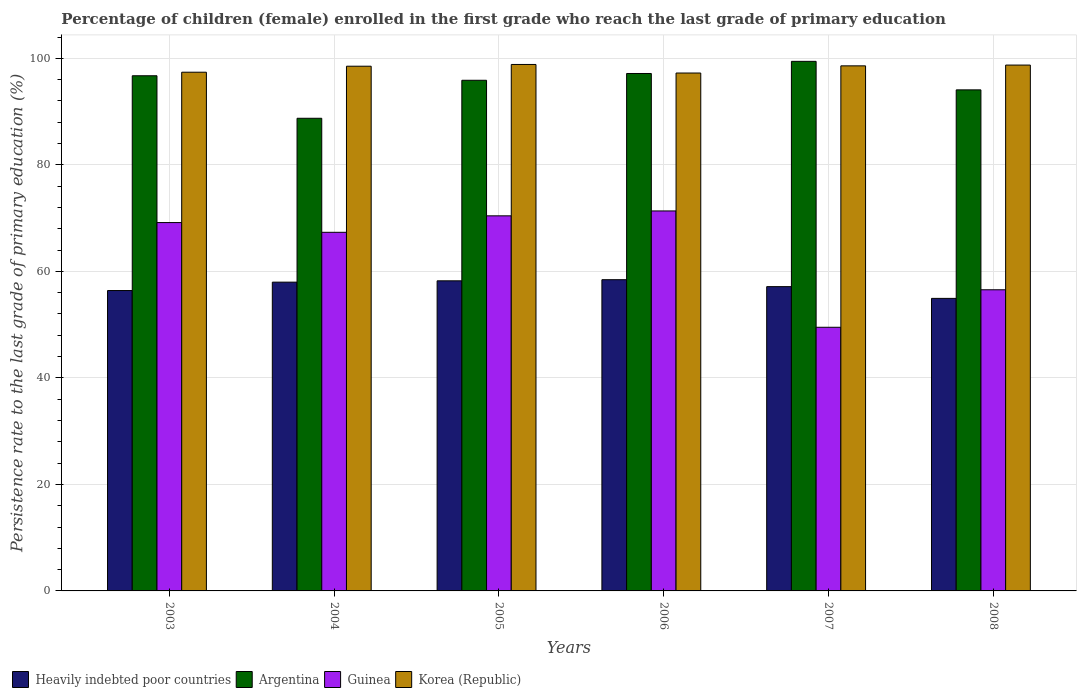How many different coloured bars are there?
Your answer should be very brief. 4. How many bars are there on the 5th tick from the right?
Your answer should be compact. 4. In how many cases, is the number of bars for a given year not equal to the number of legend labels?
Make the answer very short. 0. What is the persistence rate of children in Korea (Republic) in 2005?
Provide a short and direct response. 98.84. Across all years, what is the maximum persistence rate of children in Heavily indebted poor countries?
Offer a very short reply. 58.43. Across all years, what is the minimum persistence rate of children in Heavily indebted poor countries?
Provide a short and direct response. 54.93. In which year was the persistence rate of children in Heavily indebted poor countries maximum?
Your answer should be very brief. 2006. In which year was the persistence rate of children in Argentina minimum?
Offer a terse response. 2004. What is the total persistence rate of children in Guinea in the graph?
Your response must be concise. 384.29. What is the difference between the persistence rate of children in Korea (Republic) in 2003 and that in 2007?
Ensure brevity in your answer.  -1.2. What is the difference between the persistence rate of children in Heavily indebted poor countries in 2007 and the persistence rate of children in Korea (Republic) in 2006?
Your response must be concise. -40.1. What is the average persistence rate of children in Guinea per year?
Ensure brevity in your answer.  64.05. In the year 2007, what is the difference between the persistence rate of children in Argentina and persistence rate of children in Heavily indebted poor countries?
Provide a succinct answer. 42.3. In how many years, is the persistence rate of children in Guinea greater than 64 %?
Your response must be concise. 4. What is the ratio of the persistence rate of children in Argentina in 2003 to that in 2008?
Offer a very short reply. 1.03. Is the persistence rate of children in Guinea in 2003 less than that in 2008?
Ensure brevity in your answer.  No. What is the difference between the highest and the second highest persistence rate of children in Heavily indebted poor countries?
Make the answer very short. 0.21. What is the difference between the highest and the lowest persistence rate of children in Korea (Republic)?
Keep it short and to the point. 1.61. In how many years, is the persistence rate of children in Korea (Republic) greater than the average persistence rate of children in Korea (Republic) taken over all years?
Provide a short and direct response. 4. Is the sum of the persistence rate of children in Heavily indebted poor countries in 2006 and 2008 greater than the maximum persistence rate of children in Guinea across all years?
Provide a succinct answer. Yes. Is it the case that in every year, the sum of the persistence rate of children in Guinea and persistence rate of children in Heavily indebted poor countries is greater than the sum of persistence rate of children in Argentina and persistence rate of children in Korea (Republic)?
Make the answer very short. No. What does the 2nd bar from the right in 2006 represents?
Make the answer very short. Guinea. Is it the case that in every year, the sum of the persistence rate of children in Guinea and persistence rate of children in Heavily indebted poor countries is greater than the persistence rate of children in Korea (Republic)?
Your response must be concise. Yes. Where does the legend appear in the graph?
Give a very brief answer. Bottom left. What is the title of the graph?
Provide a short and direct response. Percentage of children (female) enrolled in the first grade who reach the last grade of primary education. What is the label or title of the X-axis?
Provide a succinct answer. Years. What is the label or title of the Y-axis?
Your answer should be very brief. Persistence rate to the last grade of primary education (%). What is the Persistence rate to the last grade of primary education (%) in Heavily indebted poor countries in 2003?
Your response must be concise. 56.4. What is the Persistence rate to the last grade of primary education (%) in Argentina in 2003?
Your answer should be compact. 96.72. What is the Persistence rate to the last grade of primary education (%) of Guinea in 2003?
Make the answer very short. 69.16. What is the Persistence rate to the last grade of primary education (%) of Korea (Republic) in 2003?
Provide a succinct answer. 97.39. What is the Persistence rate to the last grade of primary education (%) in Heavily indebted poor countries in 2004?
Keep it short and to the point. 57.97. What is the Persistence rate to the last grade of primary education (%) in Argentina in 2004?
Keep it short and to the point. 88.74. What is the Persistence rate to the last grade of primary education (%) in Guinea in 2004?
Provide a short and direct response. 67.33. What is the Persistence rate to the last grade of primary education (%) of Korea (Republic) in 2004?
Offer a very short reply. 98.51. What is the Persistence rate to the last grade of primary education (%) in Heavily indebted poor countries in 2005?
Provide a succinct answer. 58.22. What is the Persistence rate to the last grade of primary education (%) in Argentina in 2005?
Provide a succinct answer. 95.88. What is the Persistence rate to the last grade of primary education (%) of Guinea in 2005?
Your answer should be very brief. 70.42. What is the Persistence rate to the last grade of primary education (%) of Korea (Republic) in 2005?
Your answer should be very brief. 98.84. What is the Persistence rate to the last grade of primary education (%) in Heavily indebted poor countries in 2006?
Your response must be concise. 58.43. What is the Persistence rate to the last grade of primary education (%) in Argentina in 2006?
Make the answer very short. 97.15. What is the Persistence rate to the last grade of primary education (%) in Guinea in 2006?
Ensure brevity in your answer.  71.34. What is the Persistence rate to the last grade of primary education (%) of Korea (Republic) in 2006?
Offer a terse response. 97.24. What is the Persistence rate to the last grade of primary education (%) in Heavily indebted poor countries in 2007?
Keep it short and to the point. 57.13. What is the Persistence rate to the last grade of primary education (%) in Argentina in 2007?
Provide a short and direct response. 99.43. What is the Persistence rate to the last grade of primary education (%) in Guinea in 2007?
Provide a short and direct response. 49.5. What is the Persistence rate to the last grade of primary education (%) in Korea (Republic) in 2007?
Provide a short and direct response. 98.58. What is the Persistence rate to the last grade of primary education (%) in Heavily indebted poor countries in 2008?
Your answer should be very brief. 54.93. What is the Persistence rate to the last grade of primary education (%) in Argentina in 2008?
Keep it short and to the point. 94.08. What is the Persistence rate to the last grade of primary education (%) of Guinea in 2008?
Offer a very short reply. 56.54. What is the Persistence rate to the last grade of primary education (%) in Korea (Republic) in 2008?
Ensure brevity in your answer.  98.73. Across all years, what is the maximum Persistence rate to the last grade of primary education (%) of Heavily indebted poor countries?
Make the answer very short. 58.43. Across all years, what is the maximum Persistence rate to the last grade of primary education (%) in Argentina?
Provide a short and direct response. 99.43. Across all years, what is the maximum Persistence rate to the last grade of primary education (%) in Guinea?
Your response must be concise. 71.34. Across all years, what is the maximum Persistence rate to the last grade of primary education (%) in Korea (Republic)?
Offer a terse response. 98.84. Across all years, what is the minimum Persistence rate to the last grade of primary education (%) in Heavily indebted poor countries?
Your response must be concise. 54.93. Across all years, what is the minimum Persistence rate to the last grade of primary education (%) in Argentina?
Offer a terse response. 88.74. Across all years, what is the minimum Persistence rate to the last grade of primary education (%) of Guinea?
Offer a very short reply. 49.5. Across all years, what is the minimum Persistence rate to the last grade of primary education (%) of Korea (Republic)?
Your response must be concise. 97.24. What is the total Persistence rate to the last grade of primary education (%) of Heavily indebted poor countries in the graph?
Ensure brevity in your answer.  343.08. What is the total Persistence rate to the last grade of primary education (%) of Argentina in the graph?
Your answer should be compact. 571.99. What is the total Persistence rate to the last grade of primary education (%) in Guinea in the graph?
Make the answer very short. 384.29. What is the total Persistence rate to the last grade of primary education (%) in Korea (Republic) in the graph?
Make the answer very short. 589.3. What is the difference between the Persistence rate to the last grade of primary education (%) in Heavily indebted poor countries in 2003 and that in 2004?
Your answer should be very brief. -1.58. What is the difference between the Persistence rate to the last grade of primary education (%) of Argentina in 2003 and that in 2004?
Provide a short and direct response. 7.98. What is the difference between the Persistence rate to the last grade of primary education (%) of Guinea in 2003 and that in 2004?
Keep it short and to the point. 1.83. What is the difference between the Persistence rate to the last grade of primary education (%) of Korea (Republic) in 2003 and that in 2004?
Ensure brevity in your answer.  -1.13. What is the difference between the Persistence rate to the last grade of primary education (%) in Heavily indebted poor countries in 2003 and that in 2005?
Provide a succinct answer. -1.83. What is the difference between the Persistence rate to the last grade of primary education (%) of Argentina in 2003 and that in 2005?
Your response must be concise. 0.85. What is the difference between the Persistence rate to the last grade of primary education (%) in Guinea in 2003 and that in 2005?
Make the answer very short. -1.26. What is the difference between the Persistence rate to the last grade of primary education (%) in Korea (Republic) in 2003 and that in 2005?
Your answer should be compact. -1.46. What is the difference between the Persistence rate to the last grade of primary education (%) of Heavily indebted poor countries in 2003 and that in 2006?
Offer a very short reply. -2.04. What is the difference between the Persistence rate to the last grade of primary education (%) in Argentina in 2003 and that in 2006?
Offer a terse response. -0.42. What is the difference between the Persistence rate to the last grade of primary education (%) of Guinea in 2003 and that in 2006?
Keep it short and to the point. -2.18. What is the difference between the Persistence rate to the last grade of primary education (%) of Korea (Republic) in 2003 and that in 2006?
Give a very brief answer. 0.15. What is the difference between the Persistence rate to the last grade of primary education (%) of Heavily indebted poor countries in 2003 and that in 2007?
Keep it short and to the point. -0.73. What is the difference between the Persistence rate to the last grade of primary education (%) in Argentina in 2003 and that in 2007?
Make the answer very short. -2.7. What is the difference between the Persistence rate to the last grade of primary education (%) in Guinea in 2003 and that in 2007?
Provide a succinct answer. 19.66. What is the difference between the Persistence rate to the last grade of primary education (%) of Korea (Republic) in 2003 and that in 2007?
Make the answer very short. -1.2. What is the difference between the Persistence rate to the last grade of primary education (%) in Heavily indebted poor countries in 2003 and that in 2008?
Your answer should be compact. 1.47. What is the difference between the Persistence rate to the last grade of primary education (%) of Argentina in 2003 and that in 2008?
Your answer should be compact. 2.65. What is the difference between the Persistence rate to the last grade of primary education (%) in Guinea in 2003 and that in 2008?
Offer a very short reply. 12.62. What is the difference between the Persistence rate to the last grade of primary education (%) in Korea (Republic) in 2003 and that in 2008?
Your answer should be very brief. -1.34. What is the difference between the Persistence rate to the last grade of primary education (%) of Heavily indebted poor countries in 2004 and that in 2005?
Offer a terse response. -0.25. What is the difference between the Persistence rate to the last grade of primary education (%) of Argentina in 2004 and that in 2005?
Ensure brevity in your answer.  -7.13. What is the difference between the Persistence rate to the last grade of primary education (%) of Guinea in 2004 and that in 2005?
Provide a short and direct response. -3.09. What is the difference between the Persistence rate to the last grade of primary education (%) of Korea (Republic) in 2004 and that in 2005?
Your answer should be compact. -0.33. What is the difference between the Persistence rate to the last grade of primary education (%) of Heavily indebted poor countries in 2004 and that in 2006?
Provide a succinct answer. -0.46. What is the difference between the Persistence rate to the last grade of primary education (%) of Argentina in 2004 and that in 2006?
Your answer should be very brief. -8.41. What is the difference between the Persistence rate to the last grade of primary education (%) in Guinea in 2004 and that in 2006?
Keep it short and to the point. -4.01. What is the difference between the Persistence rate to the last grade of primary education (%) in Korea (Republic) in 2004 and that in 2006?
Keep it short and to the point. 1.28. What is the difference between the Persistence rate to the last grade of primary education (%) of Heavily indebted poor countries in 2004 and that in 2007?
Give a very brief answer. 0.84. What is the difference between the Persistence rate to the last grade of primary education (%) of Argentina in 2004 and that in 2007?
Offer a very short reply. -10.69. What is the difference between the Persistence rate to the last grade of primary education (%) of Guinea in 2004 and that in 2007?
Offer a very short reply. 17.83. What is the difference between the Persistence rate to the last grade of primary education (%) of Korea (Republic) in 2004 and that in 2007?
Provide a short and direct response. -0.07. What is the difference between the Persistence rate to the last grade of primary education (%) in Heavily indebted poor countries in 2004 and that in 2008?
Your response must be concise. 3.05. What is the difference between the Persistence rate to the last grade of primary education (%) of Argentina in 2004 and that in 2008?
Offer a very short reply. -5.33. What is the difference between the Persistence rate to the last grade of primary education (%) in Guinea in 2004 and that in 2008?
Offer a terse response. 10.79. What is the difference between the Persistence rate to the last grade of primary education (%) in Korea (Republic) in 2004 and that in 2008?
Ensure brevity in your answer.  -0.22. What is the difference between the Persistence rate to the last grade of primary education (%) of Heavily indebted poor countries in 2005 and that in 2006?
Make the answer very short. -0.21. What is the difference between the Persistence rate to the last grade of primary education (%) in Argentina in 2005 and that in 2006?
Provide a short and direct response. -1.27. What is the difference between the Persistence rate to the last grade of primary education (%) in Guinea in 2005 and that in 2006?
Keep it short and to the point. -0.92. What is the difference between the Persistence rate to the last grade of primary education (%) in Korea (Republic) in 2005 and that in 2006?
Give a very brief answer. 1.61. What is the difference between the Persistence rate to the last grade of primary education (%) in Heavily indebted poor countries in 2005 and that in 2007?
Your response must be concise. 1.09. What is the difference between the Persistence rate to the last grade of primary education (%) of Argentina in 2005 and that in 2007?
Your answer should be very brief. -3.55. What is the difference between the Persistence rate to the last grade of primary education (%) in Guinea in 2005 and that in 2007?
Provide a succinct answer. 20.92. What is the difference between the Persistence rate to the last grade of primary education (%) in Korea (Republic) in 2005 and that in 2007?
Your answer should be very brief. 0.26. What is the difference between the Persistence rate to the last grade of primary education (%) in Heavily indebted poor countries in 2005 and that in 2008?
Give a very brief answer. 3.3. What is the difference between the Persistence rate to the last grade of primary education (%) of Argentina in 2005 and that in 2008?
Your answer should be very brief. 1.8. What is the difference between the Persistence rate to the last grade of primary education (%) in Guinea in 2005 and that in 2008?
Provide a succinct answer. 13.88. What is the difference between the Persistence rate to the last grade of primary education (%) of Korea (Republic) in 2005 and that in 2008?
Your answer should be compact. 0.11. What is the difference between the Persistence rate to the last grade of primary education (%) of Heavily indebted poor countries in 2006 and that in 2007?
Your answer should be very brief. 1.3. What is the difference between the Persistence rate to the last grade of primary education (%) of Argentina in 2006 and that in 2007?
Keep it short and to the point. -2.28. What is the difference between the Persistence rate to the last grade of primary education (%) in Guinea in 2006 and that in 2007?
Your answer should be compact. 21.84. What is the difference between the Persistence rate to the last grade of primary education (%) of Korea (Republic) in 2006 and that in 2007?
Provide a succinct answer. -1.35. What is the difference between the Persistence rate to the last grade of primary education (%) in Heavily indebted poor countries in 2006 and that in 2008?
Make the answer very short. 3.51. What is the difference between the Persistence rate to the last grade of primary education (%) in Argentina in 2006 and that in 2008?
Provide a short and direct response. 3.07. What is the difference between the Persistence rate to the last grade of primary education (%) of Guinea in 2006 and that in 2008?
Your answer should be very brief. 14.8. What is the difference between the Persistence rate to the last grade of primary education (%) in Korea (Republic) in 2006 and that in 2008?
Your answer should be very brief. -1.5. What is the difference between the Persistence rate to the last grade of primary education (%) of Heavily indebted poor countries in 2007 and that in 2008?
Your answer should be very brief. 2.21. What is the difference between the Persistence rate to the last grade of primary education (%) in Argentina in 2007 and that in 2008?
Give a very brief answer. 5.35. What is the difference between the Persistence rate to the last grade of primary education (%) of Guinea in 2007 and that in 2008?
Provide a short and direct response. -7.04. What is the difference between the Persistence rate to the last grade of primary education (%) of Korea (Republic) in 2007 and that in 2008?
Your answer should be very brief. -0.15. What is the difference between the Persistence rate to the last grade of primary education (%) in Heavily indebted poor countries in 2003 and the Persistence rate to the last grade of primary education (%) in Argentina in 2004?
Offer a very short reply. -32.35. What is the difference between the Persistence rate to the last grade of primary education (%) of Heavily indebted poor countries in 2003 and the Persistence rate to the last grade of primary education (%) of Guinea in 2004?
Your answer should be compact. -10.93. What is the difference between the Persistence rate to the last grade of primary education (%) in Heavily indebted poor countries in 2003 and the Persistence rate to the last grade of primary education (%) in Korea (Republic) in 2004?
Provide a succinct answer. -42.12. What is the difference between the Persistence rate to the last grade of primary education (%) of Argentina in 2003 and the Persistence rate to the last grade of primary education (%) of Guinea in 2004?
Your response must be concise. 29.39. What is the difference between the Persistence rate to the last grade of primary education (%) in Argentina in 2003 and the Persistence rate to the last grade of primary education (%) in Korea (Republic) in 2004?
Offer a very short reply. -1.79. What is the difference between the Persistence rate to the last grade of primary education (%) in Guinea in 2003 and the Persistence rate to the last grade of primary education (%) in Korea (Republic) in 2004?
Offer a terse response. -29.36. What is the difference between the Persistence rate to the last grade of primary education (%) of Heavily indebted poor countries in 2003 and the Persistence rate to the last grade of primary education (%) of Argentina in 2005?
Provide a succinct answer. -39.48. What is the difference between the Persistence rate to the last grade of primary education (%) of Heavily indebted poor countries in 2003 and the Persistence rate to the last grade of primary education (%) of Guinea in 2005?
Your answer should be compact. -14.03. What is the difference between the Persistence rate to the last grade of primary education (%) of Heavily indebted poor countries in 2003 and the Persistence rate to the last grade of primary education (%) of Korea (Republic) in 2005?
Your answer should be very brief. -42.45. What is the difference between the Persistence rate to the last grade of primary education (%) of Argentina in 2003 and the Persistence rate to the last grade of primary education (%) of Guinea in 2005?
Offer a very short reply. 26.3. What is the difference between the Persistence rate to the last grade of primary education (%) of Argentina in 2003 and the Persistence rate to the last grade of primary education (%) of Korea (Republic) in 2005?
Offer a very short reply. -2.12. What is the difference between the Persistence rate to the last grade of primary education (%) of Guinea in 2003 and the Persistence rate to the last grade of primary education (%) of Korea (Republic) in 2005?
Your answer should be compact. -29.69. What is the difference between the Persistence rate to the last grade of primary education (%) of Heavily indebted poor countries in 2003 and the Persistence rate to the last grade of primary education (%) of Argentina in 2006?
Provide a short and direct response. -40.75. What is the difference between the Persistence rate to the last grade of primary education (%) of Heavily indebted poor countries in 2003 and the Persistence rate to the last grade of primary education (%) of Guinea in 2006?
Keep it short and to the point. -14.95. What is the difference between the Persistence rate to the last grade of primary education (%) in Heavily indebted poor countries in 2003 and the Persistence rate to the last grade of primary education (%) in Korea (Republic) in 2006?
Your answer should be very brief. -40.84. What is the difference between the Persistence rate to the last grade of primary education (%) of Argentina in 2003 and the Persistence rate to the last grade of primary education (%) of Guinea in 2006?
Provide a succinct answer. 25.38. What is the difference between the Persistence rate to the last grade of primary education (%) of Argentina in 2003 and the Persistence rate to the last grade of primary education (%) of Korea (Republic) in 2006?
Make the answer very short. -0.51. What is the difference between the Persistence rate to the last grade of primary education (%) of Guinea in 2003 and the Persistence rate to the last grade of primary education (%) of Korea (Republic) in 2006?
Your response must be concise. -28.08. What is the difference between the Persistence rate to the last grade of primary education (%) of Heavily indebted poor countries in 2003 and the Persistence rate to the last grade of primary education (%) of Argentina in 2007?
Your answer should be compact. -43.03. What is the difference between the Persistence rate to the last grade of primary education (%) of Heavily indebted poor countries in 2003 and the Persistence rate to the last grade of primary education (%) of Guinea in 2007?
Provide a succinct answer. 6.9. What is the difference between the Persistence rate to the last grade of primary education (%) in Heavily indebted poor countries in 2003 and the Persistence rate to the last grade of primary education (%) in Korea (Republic) in 2007?
Offer a terse response. -42.19. What is the difference between the Persistence rate to the last grade of primary education (%) of Argentina in 2003 and the Persistence rate to the last grade of primary education (%) of Guinea in 2007?
Ensure brevity in your answer.  47.22. What is the difference between the Persistence rate to the last grade of primary education (%) in Argentina in 2003 and the Persistence rate to the last grade of primary education (%) in Korea (Republic) in 2007?
Your response must be concise. -1.86. What is the difference between the Persistence rate to the last grade of primary education (%) of Guinea in 2003 and the Persistence rate to the last grade of primary education (%) of Korea (Republic) in 2007?
Your answer should be compact. -29.43. What is the difference between the Persistence rate to the last grade of primary education (%) in Heavily indebted poor countries in 2003 and the Persistence rate to the last grade of primary education (%) in Argentina in 2008?
Your answer should be very brief. -37.68. What is the difference between the Persistence rate to the last grade of primary education (%) of Heavily indebted poor countries in 2003 and the Persistence rate to the last grade of primary education (%) of Guinea in 2008?
Provide a succinct answer. -0.14. What is the difference between the Persistence rate to the last grade of primary education (%) of Heavily indebted poor countries in 2003 and the Persistence rate to the last grade of primary education (%) of Korea (Republic) in 2008?
Provide a short and direct response. -42.33. What is the difference between the Persistence rate to the last grade of primary education (%) of Argentina in 2003 and the Persistence rate to the last grade of primary education (%) of Guinea in 2008?
Your answer should be very brief. 40.18. What is the difference between the Persistence rate to the last grade of primary education (%) of Argentina in 2003 and the Persistence rate to the last grade of primary education (%) of Korea (Republic) in 2008?
Your answer should be compact. -2.01. What is the difference between the Persistence rate to the last grade of primary education (%) of Guinea in 2003 and the Persistence rate to the last grade of primary education (%) of Korea (Republic) in 2008?
Make the answer very short. -29.57. What is the difference between the Persistence rate to the last grade of primary education (%) of Heavily indebted poor countries in 2004 and the Persistence rate to the last grade of primary education (%) of Argentina in 2005?
Give a very brief answer. -37.9. What is the difference between the Persistence rate to the last grade of primary education (%) in Heavily indebted poor countries in 2004 and the Persistence rate to the last grade of primary education (%) in Guinea in 2005?
Provide a short and direct response. -12.45. What is the difference between the Persistence rate to the last grade of primary education (%) of Heavily indebted poor countries in 2004 and the Persistence rate to the last grade of primary education (%) of Korea (Republic) in 2005?
Make the answer very short. -40.87. What is the difference between the Persistence rate to the last grade of primary education (%) in Argentina in 2004 and the Persistence rate to the last grade of primary education (%) in Guinea in 2005?
Keep it short and to the point. 18.32. What is the difference between the Persistence rate to the last grade of primary education (%) in Argentina in 2004 and the Persistence rate to the last grade of primary education (%) in Korea (Republic) in 2005?
Offer a very short reply. -10.1. What is the difference between the Persistence rate to the last grade of primary education (%) in Guinea in 2004 and the Persistence rate to the last grade of primary education (%) in Korea (Republic) in 2005?
Make the answer very short. -31.51. What is the difference between the Persistence rate to the last grade of primary education (%) in Heavily indebted poor countries in 2004 and the Persistence rate to the last grade of primary education (%) in Argentina in 2006?
Provide a short and direct response. -39.17. What is the difference between the Persistence rate to the last grade of primary education (%) in Heavily indebted poor countries in 2004 and the Persistence rate to the last grade of primary education (%) in Guinea in 2006?
Give a very brief answer. -13.37. What is the difference between the Persistence rate to the last grade of primary education (%) of Heavily indebted poor countries in 2004 and the Persistence rate to the last grade of primary education (%) of Korea (Republic) in 2006?
Provide a short and direct response. -39.26. What is the difference between the Persistence rate to the last grade of primary education (%) of Argentina in 2004 and the Persistence rate to the last grade of primary education (%) of Guinea in 2006?
Your response must be concise. 17.4. What is the difference between the Persistence rate to the last grade of primary education (%) of Argentina in 2004 and the Persistence rate to the last grade of primary education (%) of Korea (Republic) in 2006?
Offer a terse response. -8.49. What is the difference between the Persistence rate to the last grade of primary education (%) in Guinea in 2004 and the Persistence rate to the last grade of primary education (%) in Korea (Republic) in 2006?
Offer a very short reply. -29.9. What is the difference between the Persistence rate to the last grade of primary education (%) in Heavily indebted poor countries in 2004 and the Persistence rate to the last grade of primary education (%) in Argentina in 2007?
Give a very brief answer. -41.45. What is the difference between the Persistence rate to the last grade of primary education (%) of Heavily indebted poor countries in 2004 and the Persistence rate to the last grade of primary education (%) of Guinea in 2007?
Offer a terse response. 8.47. What is the difference between the Persistence rate to the last grade of primary education (%) of Heavily indebted poor countries in 2004 and the Persistence rate to the last grade of primary education (%) of Korea (Republic) in 2007?
Your answer should be very brief. -40.61. What is the difference between the Persistence rate to the last grade of primary education (%) in Argentina in 2004 and the Persistence rate to the last grade of primary education (%) in Guinea in 2007?
Give a very brief answer. 39.24. What is the difference between the Persistence rate to the last grade of primary education (%) of Argentina in 2004 and the Persistence rate to the last grade of primary education (%) of Korea (Republic) in 2007?
Your answer should be compact. -9.84. What is the difference between the Persistence rate to the last grade of primary education (%) of Guinea in 2004 and the Persistence rate to the last grade of primary education (%) of Korea (Republic) in 2007?
Ensure brevity in your answer.  -31.25. What is the difference between the Persistence rate to the last grade of primary education (%) of Heavily indebted poor countries in 2004 and the Persistence rate to the last grade of primary education (%) of Argentina in 2008?
Offer a terse response. -36.1. What is the difference between the Persistence rate to the last grade of primary education (%) of Heavily indebted poor countries in 2004 and the Persistence rate to the last grade of primary education (%) of Guinea in 2008?
Ensure brevity in your answer.  1.43. What is the difference between the Persistence rate to the last grade of primary education (%) in Heavily indebted poor countries in 2004 and the Persistence rate to the last grade of primary education (%) in Korea (Republic) in 2008?
Provide a succinct answer. -40.76. What is the difference between the Persistence rate to the last grade of primary education (%) in Argentina in 2004 and the Persistence rate to the last grade of primary education (%) in Guinea in 2008?
Offer a very short reply. 32.2. What is the difference between the Persistence rate to the last grade of primary education (%) in Argentina in 2004 and the Persistence rate to the last grade of primary education (%) in Korea (Republic) in 2008?
Your answer should be compact. -9.99. What is the difference between the Persistence rate to the last grade of primary education (%) of Guinea in 2004 and the Persistence rate to the last grade of primary education (%) of Korea (Republic) in 2008?
Your answer should be very brief. -31.4. What is the difference between the Persistence rate to the last grade of primary education (%) of Heavily indebted poor countries in 2005 and the Persistence rate to the last grade of primary education (%) of Argentina in 2006?
Keep it short and to the point. -38.93. What is the difference between the Persistence rate to the last grade of primary education (%) in Heavily indebted poor countries in 2005 and the Persistence rate to the last grade of primary education (%) in Guinea in 2006?
Provide a succinct answer. -13.12. What is the difference between the Persistence rate to the last grade of primary education (%) in Heavily indebted poor countries in 2005 and the Persistence rate to the last grade of primary education (%) in Korea (Republic) in 2006?
Give a very brief answer. -39.01. What is the difference between the Persistence rate to the last grade of primary education (%) of Argentina in 2005 and the Persistence rate to the last grade of primary education (%) of Guinea in 2006?
Offer a terse response. 24.53. What is the difference between the Persistence rate to the last grade of primary education (%) of Argentina in 2005 and the Persistence rate to the last grade of primary education (%) of Korea (Republic) in 2006?
Your answer should be very brief. -1.36. What is the difference between the Persistence rate to the last grade of primary education (%) in Guinea in 2005 and the Persistence rate to the last grade of primary education (%) in Korea (Republic) in 2006?
Your answer should be very brief. -26.81. What is the difference between the Persistence rate to the last grade of primary education (%) in Heavily indebted poor countries in 2005 and the Persistence rate to the last grade of primary education (%) in Argentina in 2007?
Keep it short and to the point. -41.21. What is the difference between the Persistence rate to the last grade of primary education (%) of Heavily indebted poor countries in 2005 and the Persistence rate to the last grade of primary education (%) of Guinea in 2007?
Your response must be concise. 8.72. What is the difference between the Persistence rate to the last grade of primary education (%) of Heavily indebted poor countries in 2005 and the Persistence rate to the last grade of primary education (%) of Korea (Republic) in 2007?
Your answer should be compact. -40.36. What is the difference between the Persistence rate to the last grade of primary education (%) of Argentina in 2005 and the Persistence rate to the last grade of primary education (%) of Guinea in 2007?
Provide a succinct answer. 46.38. What is the difference between the Persistence rate to the last grade of primary education (%) of Argentina in 2005 and the Persistence rate to the last grade of primary education (%) of Korea (Republic) in 2007?
Provide a short and direct response. -2.71. What is the difference between the Persistence rate to the last grade of primary education (%) of Guinea in 2005 and the Persistence rate to the last grade of primary education (%) of Korea (Republic) in 2007?
Give a very brief answer. -28.16. What is the difference between the Persistence rate to the last grade of primary education (%) of Heavily indebted poor countries in 2005 and the Persistence rate to the last grade of primary education (%) of Argentina in 2008?
Offer a terse response. -35.85. What is the difference between the Persistence rate to the last grade of primary education (%) of Heavily indebted poor countries in 2005 and the Persistence rate to the last grade of primary education (%) of Guinea in 2008?
Your response must be concise. 1.68. What is the difference between the Persistence rate to the last grade of primary education (%) of Heavily indebted poor countries in 2005 and the Persistence rate to the last grade of primary education (%) of Korea (Republic) in 2008?
Provide a short and direct response. -40.51. What is the difference between the Persistence rate to the last grade of primary education (%) of Argentina in 2005 and the Persistence rate to the last grade of primary education (%) of Guinea in 2008?
Your answer should be very brief. 39.33. What is the difference between the Persistence rate to the last grade of primary education (%) of Argentina in 2005 and the Persistence rate to the last grade of primary education (%) of Korea (Republic) in 2008?
Your answer should be compact. -2.86. What is the difference between the Persistence rate to the last grade of primary education (%) in Guinea in 2005 and the Persistence rate to the last grade of primary education (%) in Korea (Republic) in 2008?
Your response must be concise. -28.31. What is the difference between the Persistence rate to the last grade of primary education (%) in Heavily indebted poor countries in 2006 and the Persistence rate to the last grade of primary education (%) in Argentina in 2007?
Give a very brief answer. -40.99. What is the difference between the Persistence rate to the last grade of primary education (%) in Heavily indebted poor countries in 2006 and the Persistence rate to the last grade of primary education (%) in Guinea in 2007?
Your answer should be very brief. 8.93. What is the difference between the Persistence rate to the last grade of primary education (%) in Heavily indebted poor countries in 2006 and the Persistence rate to the last grade of primary education (%) in Korea (Republic) in 2007?
Offer a very short reply. -40.15. What is the difference between the Persistence rate to the last grade of primary education (%) of Argentina in 2006 and the Persistence rate to the last grade of primary education (%) of Guinea in 2007?
Give a very brief answer. 47.65. What is the difference between the Persistence rate to the last grade of primary education (%) of Argentina in 2006 and the Persistence rate to the last grade of primary education (%) of Korea (Republic) in 2007?
Offer a very short reply. -1.44. What is the difference between the Persistence rate to the last grade of primary education (%) in Guinea in 2006 and the Persistence rate to the last grade of primary education (%) in Korea (Republic) in 2007?
Ensure brevity in your answer.  -27.24. What is the difference between the Persistence rate to the last grade of primary education (%) of Heavily indebted poor countries in 2006 and the Persistence rate to the last grade of primary education (%) of Argentina in 2008?
Ensure brevity in your answer.  -35.64. What is the difference between the Persistence rate to the last grade of primary education (%) of Heavily indebted poor countries in 2006 and the Persistence rate to the last grade of primary education (%) of Guinea in 2008?
Your response must be concise. 1.89. What is the difference between the Persistence rate to the last grade of primary education (%) of Heavily indebted poor countries in 2006 and the Persistence rate to the last grade of primary education (%) of Korea (Republic) in 2008?
Offer a terse response. -40.3. What is the difference between the Persistence rate to the last grade of primary education (%) of Argentina in 2006 and the Persistence rate to the last grade of primary education (%) of Guinea in 2008?
Keep it short and to the point. 40.61. What is the difference between the Persistence rate to the last grade of primary education (%) of Argentina in 2006 and the Persistence rate to the last grade of primary education (%) of Korea (Republic) in 2008?
Keep it short and to the point. -1.58. What is the difference between the Persistence rate to the last grade of primary education (%) in Guinea in 2006 and the Persistence rate to the last grade of primary education (%) in Korea (Republic) in 2008?
Offer a terse response. -27.39. What is the difference between the Persistence rate to the last grade of primary education (%) of Heavily indebted poor countries in 2007 and the Persistence rate to the last grade of primary education (%) of Argentina in 2008?
Offer a terse response. -36.94. What is the difference between the Persistence rate to the last grade of primary education (%) of Heavily indebted poor countries in 2007 and the Persistence rate to the last grade of primary education (%) of Guinea in 2008?
Give a very brief answer. 0.59. What is the difference between the Persistence rate to the last grade of primary education (%) of Heavily indebted poor countries in 2007 and the Persistence rate to the last grade of primary education (%) of Korea (Republic) in 2008?
Your response must be concise. -41.6. What is the difference between the Persistence rate to the last grade of primary education (%) of Argentina in 2007 and the Persistence rate to the last grade of primary education (%) of Guinea in 2008?
Offer a very short reply. 42.89. What is the difference between the Persistence rate to the last grade of primary education (%) in Argentina in 2007 and the Persistence rate to the last grade of primary education (%) in Korea (Republic) in 2008?
Offer a very short reply. 0.7. What is the difference between the Persistence rate to the last grade of primary education (%) of Guinea in 2007 and the Persistence rate to the last grade of primary education (%) of Korea (Republic) in 2008?
Make the answer very short. -49.23. What is the average Persistence rate to the last grade of primary education (%) of Heavily indebted poor countries per year?
Your answer should be compact. 57.18. What is the average Persistence rate to the last grade of primary education (%) of Argentina per year?
Make the answer very short. 95.33. What is the average Persistence rate to the last grade of primary education (%) in Guinea per year?
Keep it short and to the point. 64.05. What is the average Persistence rate to the last grade of primary education (%) in Korea (Republic) per year?
Give a very brief answer. 98.22. In the year 2003, what is the difference between the Persistence rate to the last grade of primary education (%) of Heavily indebted poor countries and Persistence rate to the last grade of primary education (%) of Argentina?
Ensure brevity in your answer.  -40.33. In the year 2003, what is the difference between the Persistence rate to the last grade of primary education (%) in Heavily indebted poor countries and Persistence rate to the last grade of primary education (%) in Guinea?
Give a very brief answer. -12.76. In the year 2003, what is the difference between the Persistence rate to the last grade of primary education (%) in Heavily indebted poor countries and Persistence rate to the last grade of primary education (%) in Korea (Republic)?
Your answer should be very brief. -40.99. In the year 2003, what is the difference between the Persistence rate to the last grade of primary education (%) in Argentina and Persistence rate to the last grade of primary education (%) in Guinea?
Your answer should be compact. 27.56. In the year 2003, what is the difference between the Persistence rate to the last grade of primary education (%) of Argentina and Persistence rate to the last grade of primary education (%) of Korea (Republic)?
Your answer should be very brief. -0.67. In the year 2003, what is the difference between the Persistence rate to the last grade of primary education (%) in Guinea and Persistence rate to the last grade of primary education (%) in Korea (Republic)?
Provide a succinct answer. -28.23. In the year 2004, what is the difference between the Persistence rate to the last grade of primary education (%) of Heavily indebted poor countries and Persistence rate to the last grade of primary education (%) of Argentina?
Offer a terse response. -30.77. In the year 2004, what is the difference between the Persistence rate to the last grade of primary education (%) in Heavily indebted poor countries and Persistence rate to the last grade of primary education (%) in Guinea?
Your response must be concise. -9.36. In the year 2004, what is the difference between the Persistence rate to the last grade of primary education (%) of Heavily indebted poor countries and Persistence rate to the last grade of primary education (%) of Korea (Republic)?
Keep it short and to the point. -40.54. In the year 2004, what is the difference between the Persistence rate to the last grade of primary education (%) of Argentina and Persistence rate to the last grade of primary education (%) of Guinea?
Your response must be concise. 21.41. In the year 2004, what is the difference between the Persistence rate to the last grade of primary education (%) of Argentina and Persistence rate to the last grade of primary education (%) of Korea (Republic)?
Ensure brevity in your answer.  -9.77. In the year 2004, what is the difference between the Persistence rate to the last grade of primary education (%) in Guinea and Persistence rate to the last grade of primary education (%) in Korea (Republic)?
Provide a succinct answer. -31.18. In the year 2005, what is the difference between the Persistence rate to the last grade of primary education (%) in Heavily indebted poor countries and Persistence rate to the last grade of primary education (%) in Argentina?
Offer a terse response. -37.65. In the year 2005, what is the difference between the Persistence rate to the last grade of primary education (%) of Heavily indebted poor countries and Persistence rate to the last grade of primary education (%) of Guinea?
Keep it short and to the point. -12.2. In the year 2005, what is the difference between the Persistence rate to the last grade of primary education (%) in Heavily indebted poor countries and Persistence rate to the last grade of primary education (%) in Korea (Republic)?
Provide a succinct answer. -40.62. In the year 2005, what is the difference between the Persistence rate to the last grade of primary education (%) of Argentina and Persistence rate to the last grade of primary education (%) of Guinea?
Give a very brief answer. 25.45. In the year 2005, what is the difference between the Persistence rate to the last grade of primary education (%) in Argentina and Persistence rate to the last grade of primary education (%) in Korea (Republic)?
Make the answer very short. -2.97. In the year 2005, what is the difference between the Persistence rate to the last grade of primary education (%) in Guinea and Persistence rate to the last grade of primary education (%) in Korea (Republic)?
Provide a short and direct response. -28.42. In the year 2006, what is the difference between the Persistence rate to the last grade of primary education (%) in Heavily indebted poor countries and Persistence rate to the last grade of primary education (%) in Argentina?
Provide a succinct answer. -38.71. In the year 2006, what is the difference between the Persistence rate to the last grade of primary education (%) of Heavily indebted poor countries and Persistence rate to the last grade of primary education (%) of Guinea?
Give a very brief answer. -12.91. In the year 2006, what is the difference between the Persistence rate to the last grade of primary education (%) of Heavily indebted poor countries and Persistence rate to the last grade of primary education (%) of Korea (Republic)?
Your answer should be very brief. -38.8. In the year 2006, what is the difference between the Persistence rate to the last grade of primary education (%) in Argentina and Persistence rate to the last grade of primary education (%) in Guinea?
Give a very brief answer. 25.81. In the year 2006, what is the difference between the Persistence rate to the last grade of primary education (%) in Argentina and Persistence rate to the last grade of primary education (%) in Korea (Republic)?
Offer a very short reply. -0.09. In the year 2006, what is the difference between the Persistence rate to the last grade of primary education (%) in Guinea and Persistence rate to the last grade of primary education (%) in Korea (Republic)?
Provide a short and direct response. -25.89. In the year 2007, what is the difference between the Persistence rate to the last grade of primary education (%) in Heavily indebted poor countries and Persistence rate to the last grade of primary education (%) in Argentina?
Give a very brief answer. -42.3. In the year 2007, what is the difference between the Persistence rate to the last grade of primary education (%) in Heavily indebted poor countries and Persistence rate to the last grade of primary education (%) in Guinea?
Provide a succinct answer. 7.63. In the year 2007, what is the difference between the Persistence rate to the last grade of primary education (%) in Heavily indebted poor countries and Persistence rate to the last grade of primary education (%) in Korea (Republic)?
Your answer should be compact. -41.45. In the year 2007, what is the difference between the Persistence rate to the last grade of primary education (%) of Argentina and Persistence rate to the last grade of primary education (%) of Guinea?
Keep it short and to the point. 49.93. In the year 2007, what is the difference between the Persistence rate to the last grade of primary education (%) of Argentina and Persistence rate to the last grade of primary education (%) of Korea (Republic)?
Ensure brevity in your answer.  0.84. In the year 2007, what is the difference between the Persistence rate to the last grade of primary education (%) in Guinea and Persistence rate to the last grade of primary education (%) in Korea (Republic)?
Offer a terse response. -49.08. In the year 2008, what is the difference between the Persistence rate to the last grade of primary education (%) in Heavily indebted poor countries and Persistence rate to the last grade of primary education (%) in Argentina?
Provide a succinct answer. -39.15. In the year 2008, what is the difference between the Persistence rate to the last grade of primary education (%) of Heavily indebted poor countries and Persistence rate to the last grade of primary education (%) of Guinea?
Provide a short and direct response. -1.61. In the year 2008, what is the difference between the Persistence rate to the last grade of primary education (%) in Heavily indebted poor countries and Persistence rate to the last grade of primary education (%) in Korea (Republic)?
Your answer should be very brief. -43.81. In the year 2008, what is the difference between the Persistence rate to the last grade of primary education (%) of Argentina and Persistence rate to the last grade of primary education (%) of Guinea?
Provide a short and direct response. 37.53. In the year 2008, what is the difference between the Persistence rate to the last grade of primary education (%) of Argentina and Persistence rate to the last grade of primary education (%) of Korea (Republic)?
Give a very brief answer. -4.66. In the year 2008, what is the difference between the Persistence rate to the last grade of primary education (%) of Guinea and Persistence rate to the last grade of primary education (%) of Korea (Republic)?
Ensure brevity in your answer.  -42.19. What is the ratio of the Persistence rate to the last grade of primary education (%) of Heavily indebted poor countries in 2003 to that in 2004?
Provide a short and direct response. 0.97. What is the ratio of the Persistence rate to the last grade of primary education (%) in Argentina in 2003 to that in 2004?
Your answer should be very brief. 1.09. What is the ratio of the Persistence rate to the last grade of primary education (%) in Guinea in 2003 to that in 2004?
Make the answer very short. 1.03. What is the ratio of the Persistence rate to the last grade of primary education (%) of Korea (Republic) in 2003 to that in 2004?
Offer a very short reply. 0.99. What is the ratio of the Persistence rate to the last grade of primary education (%) of Heavily indebted poor countries in 2003 to that in 2005?
Your answer should be compact. 0.97. What is the ratio of the Persistence rate to the last grade of primary education (%) of Argentina in 2003 to that in 2005?
Your answer should be very brief. 1.01. What is the ratio of the Persistence rate to the last grade of primary education (%) of Guinea in 2003 to that in 2005?
Make the answer very short. 0.98. What is the ratio of the Persistence rate to the last grade of primary education (%) of Heavily indebted poor countries in 2003 to that in 2006?
Offer a very short reply. 0.97. What is the ratio of the Persistence rate to the last grade of primary education (%) in Guinea in 2003 to that in 2006?
Keep it short and to the point. 0.97. What is the ratio of the Persistence rate to the last grade of primary education (%) in Korea (Republic) in 2003 to that in 2006?
Offer a very short reply. 1. What is the ratio of the Persistence rate to the last grade of primary education (%) in Heavily indebted poor countries in 2003 to that in 2007?
Your response must be concise. 0.99. What is the ratio of the Persistence rate to the last grade of primary education (%) in Argentina in 2003 to that in 2007?
Offer a terse response. 0.97. What is the ratio of the Persistence rate to the last grade of primary education (%) of Guinea in 2003 to that in 2007?
Give a very brief answer. 1.4. What is the ratio of the Persistence rate to the last grade of primary education (%) of Korea (Republic) in 2003 to that in 2007?
Ensure brevity in your answer.  0.99. What is the ratio of the Persistence rate to the last grade of primary education (%) in Heavily indebted poor countries in 2003 to that in 2008?
Offer a terse response. 1.03. What is the ratio of the Persistence rate to the last grade of primary education (%) in Argentina in 2003 to that in 2008?
Your response must be concise. 1.03. What is the ratio of the Persistence rate to the last grade of primary education (%) of Guinea in 2003 to that in 2008?
Your answer should be very brief. 1.22. What is the ratio of the Persistence rate to the last grade of primary education (%) of Korea (Republic) in 2003 to that in 2008?
Your answer should be compact. 0.99. What is the ratio of the Persistence rate to the last grade of primary education (%) in Heavily indebted poor countries in 2004 to that in 2005?
Your response must be concise. 1. What is the ratio of the Persistence rate to the last grade of primary education (%) of Argentina in 2004 to that in 2005?
Provide a succinct answer. 0.93. What is the ratio of the Persistence rate to the last grade of primary education (%) of Guinea in 2004 to that in 2005?
Your response must be concise. 0.96. What is the ratio of the Persistence rate to the last grade of primary education (%) of Korea (Republic) in 2004 to that in 2005?
Ensure brevity in your answer.  1. What is the ratio of the Persistence rate to the last grade of primary education (%) of Heavily indebted poor countries in 2004 to that in 2006?
Ensure brevity in your answer.  0.99. What is the ratio of the Persistence rate to the last grade of primary education (%) in Argentina in 2004 to that in 2006?
Your response must be concise. 0.91. What is the ratio of the Persistence rate to the last grade of primary education (%) of Guinea in 2004 to that in 2006?
Offer a very short reply. 0.94. What is the ratio of the Persistence rate to the last grade of primary education (%) of Korea (Republic) in 2004 to that in 2006?
Provide a short and direct response. 1.01. What is the ratio of the Persistence rate to the last grade of primary education (%) of Heavily indebted poor countries in 2004 to that in 2007?
Ensure brevity in your answer.  1.01. What is the ratio of the Persistence rate to the last grade of primary education (%) in Argentina in 2004 to that in 2007?
Your response must be concise. 0.89. What is the ratio of the Persistence rate to the last grade of primary education (%) of Guinea in 2004 to that in 2007?
Your answer should be compact. 1.36. What is the ratio of the Persistence rate to the last grade of primary education (%) in Korea (Republic) in 2004 to that in 2007?
Keep it short and to the point. 1. What is the ratio of the Persistence rate to the last grade of primary education (%) of Heavily indebted poor countries in 2004 to that in 2008?
Ensure brevity in your answer.  1.06. What is the ratio of the Persistence rate to the last grade of primary education (%) of Argentina in 2004 to that in 2008?
Keep it short and to the point. 0.94. What is the ratio of the Persistence rate to the last grade of primary education (%) of Guinea in 2004 to that in 2008?
Provide a succinct answer. 1.19. What is the ratio of the Persistence rate to the last grade of primary education (%) of Korea (Republic) in 2004 to that in 2008?
Your response must be concise. 1. What is the ratio of the Persistence rate to the last grade of primary education (%) in Heavily indebted poor countries in 2005 to that in 2006?
Provide a succinct answer. 1. What is the ratio of the Persistence rate to the last grade of primary education (%) of Argentina in 2005 to that in 2006?
Make the answer very short. 0.99. What is the ratio of the Persistence rate to the last grade of primary education (%) in Guinea in 2005 to that in 2006?
Provide a short and direct response. 0.99. What is the ratio of the Persistence rate to the last grade of primary education (%) in Korea (Republic) in 2005 to that in 2006?
Offer a terse response. 1.02. What is the ratio of the Persistence rate to the last grade of primary education (%) in Heavily indebted poor countries in 2005 to that in 2007?
Your response must be concise. 1.02. What is the ratio of the Persistence rate to the last grade of primary education (%) in Guinea in 2005 to that in 2007?
Your response must be concise. 1.42. What is the ratio of the Persistence rate to the last grade of primary education (%) of Heavily indebted poor countries in 2005 to that in 2008?
Provide a succinct answer. 1.06. What is the ratio of the Persistence rate to the last grade of primary education (%) of Argentina in 2005 to that in 2008?
Provide a short and direct response. 1.02. What is the ratio of the Persistence rate to the last grade of primary education (%) of Guinea in 2005 to that in 2008?
Make the answer very short. 1.25. What is the ratio of the Persistence rate to the last grade of primary education (%) of Heavily indebted poor countries in 2006 to that in 2007?
Your response must be concise. 1.02. What is the ratio of the Persistence rate to the last grade of primary education (%) in Argentina in 2006 to that in 2007?
Keep it short and to the point. 0.98. What is the ratio of the Persistence rate to the last grade of primary education (%) in Guinea in 2006 to that in 2007?
Offer a very short reply. 1.44. What is the ratio of the Persistence rate to the last grade of primary education (%) in Korea (Republic) in 2006 to that in 2007?
Ensure brevity in your answer.  0.99. What is the ratio of the Persistence rate to the last grade of primary education (%) of Heavily indebted poor countries in 2006 to that in 2008?
Give a very brief answer. 1.06. What is the ratio of the Persistence rate to the last grade of primary education (%) in Argentina in 2006 to that in 2008?
Your answer should be very brief. 1.03. What is the ratio of the Persistence rate to the last grade of primary education (%) of Guinea in 2006 to that in 2008?
Your answer should be very brief. 1.26. What is the ratio of the Persistence rate to the last grade of primary education (%) of Korea (Republic) in 2006 to that in 2008?
Your answer should be compact. 0.98. What is the ratio of the Persistence rate to the last grade of primary education (%) in Heavily indebted poor countries in 2007 to that in 2008?
Offer a very short reply. 1.04. What is the ratio of the Persistence rate to the last grade of primary education (%) in Argentina in 2007 to that in 2008?
Provide a short and direct response. 1.06. What is the ratio of the Persistence rate to the last grade of primary education (%) in Guinea in 2007 to that in 2008?
Ensure brevity in your answer.  0.88. What is the ratio of the Persistence rate to the last grade of primary education (%) of Korea (Republic) in 2007 to that in 2008?
Ensure brevity in your answer.  1. What is the difference between the highest and the second highest Persistence rate to the last grade of primary education (%) of Heavily indebted poor countries?
Ensure brevity in your answer.  0.21. What is the difference between the highest and the second highest Persistence rate to the last grade of primary education (%) in Argentina?
Your response must be concise. 2.28. What is the difference between the highest and the second highest Persistence rate to the last grade of primary education (%) in Guinea?
Offer a very short reply. 0.92. What is the difference between the highest and the second highest Persistence rate to the last grade of primary education (%) of Korea (Republic)?
Your answer should be very brief. 0.11. What is the difference between the highest and the lowest Persistence rate to the last grade of primary education (%) of Heavily indebted poor countries?
Provide a succinct answer. 3.51. What is the difference between the highest and the lowest Persistence rate to the last grade of primary education (%) of Argentina?
Keep it short and to the point. 10.69. What is the difference between the highest and the lowest Persistence rate to the last grade of primary education (%) of Guinea?
Provide a succinct answer. 21.84. What is the difference between the highest and the lowest Persistence rate to the last grade of primary education (%) in Korea (Republic)?
Provide a short and direct response. 1.61. 